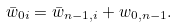<formula> <loc_0><loc_0><loc_500><loc_500>\bar { w } _ { 0 i } = \bar { w } _ { n - 1 , i } + w _ { 0 , n - 1 } .</formula> 